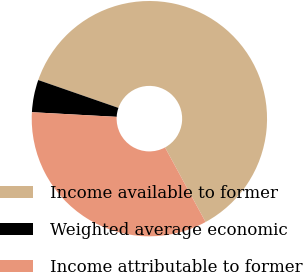Convert chart. <chart><loc_0><loc_0><loc_500><loc_500><pie_chart><fcel>Income available to former<fcel>Weighted average economic<fcel>Income attributable to former<nl><fcel>61.75%<fcel>4.45%<fcel>33.8%<nl></chart> 